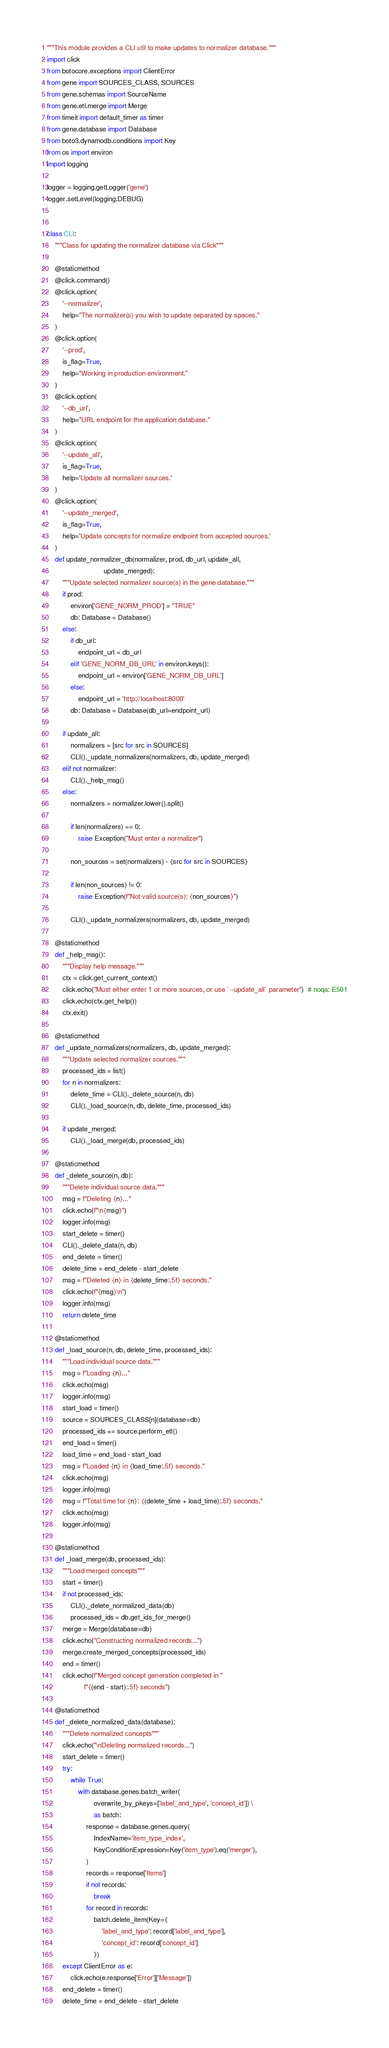<code> <loc_0><loc_0><loc_500><loc_500><_Python_>"""This module provides a CLI util to make updates to normalizer database."""
import click
from botocore.exceptions import ClientError
from gene import SOURCES_CLASS, SOURCES
from gene.schemas import SourceName
from gene.etl.merge import Merge
from timeit import default_timer as timer
from gene.database import Database
from boto3.dynamodb.conditions import Key
from os import environ
import logging

logger = logging.getLogger('gene')
logger.setLevel(logging.DEBUG)


class CLI:
    """Class for updating the normalizer database via Click"""

    @staticmethod
    @click.command()
    @click.option(
        '--normalizer',
        help="The normalizer(s) you wish to update separated by spaces."
    )
    @click.option(
        '--prod',
        is_flag=True,
        help="Working in production environment."
    )
    @click.option(
        '--db_url',
        help="URL endpoint for the application database."
    )
    @click.option(
        '--update_all',
        is_flag=True,
        help='Update all normalizer sources.'
    )
    @click.option(
        '--update_merged',
        is_flag=True,
        help='Update concepts for normalize endpoint from accepted sources.'
    )
    def update_normalizer_db(normalizer, prod, db_url, update_all,
                             update_merged):
        """Update selected normalizer source(s) in the gene database."""
        if prod:
            environ['GENE_NORM_PROD'] = "TRUE"
            db: Database = Database()
        else:
            if db_url:
                endpoint_url = db_url
            elif 'GENE_NORM_DB_URL' in environ.keys():
                endpoint_url = environ['GENE_NORM_DB_URL']
            else:
                endpoint_url = 'http://localhost:8000'
            db: Database = Database(db_url=endpoint_url)

        if update_all:
            normalizers = [src for src in SOURCES]
            CLI()._update_normalizers(normalizers, db, update_merged)
        elif not normalizer:
            CLI()._help_msg()
        else:
            normalizers = normalizer.lower().split()

            if len(normalizers) == 0:
                raise Exception("Must enter a normalizer")

            non_sources = set(normalizers) - {src for src in SOURCES}

            if len(non_sources) != 0:
                raise Exception(f"Not valid source(s): {non_sources}")

            CLI()._update_normalizers(normalizers, db, update_merged)

    @staticmethod
    def _help_msg():
        """Display help message."""
        ctx = click.get_current_context()
        click.echo("Must either enter 1 or more sources, or use `--update_all` parameter")  # noqa: E501
        click.echo(ctx.get_help())
        ctx.exit()

    @staticmethod
    def _update_normalizers(normalizers, db, update_merged):
        """Update selected normalizer sources."""
        processed_ids = list()
        for n in normalizers:
            delete_time = CLI()._delete_source(n, db)
            CLI()._load_source(n, db, delete_time, processed_ids)

        if update_merged:
            CLI()._load_merge(db, processed_ids)

    @staticmethod
    def _delete_source(n, db):
        """Delete individual source data."""
        msg = f"Deleting {n}..."
        click.echo(f"\n{msg}")
        logger.info(msg)
        start_delete = timer()
        CLI()._delete_data(n, db)
        end_delete = timer()
        delete_time = end_delete - start_delete
        msg = f"Deleted {n} in {delete_time:.5f} seconds."
        click.echo(f"{msg}\n")
        logger.info(msg)
        return delete_time

    @staticmethod
    def _load_source(n, db, delete_time, processed_ids):
        """Load individual source data."""
        msg = f"Loading {n}..."
        click.echo(msg)
        logger.info(msg)
        start_load = timer()
        source = SOURCES_CLASS[n](database=db)
        processed_ids += source.perform_etl()
        end_load = timer()
        load_time = end_load - start_load
        msg = f"Loaded {n} in {load_time:.5f} seconds."
        click.echo(msg)
        logger.info(msg)
        msg = f"Total time for {n}: {(delete_time + load_time):.5f} seconds."
        click.echo(msg)
        logger.info(msg)

    @staticmethod
    def _load_merge(db, processed_ids):
        """Load merged concepts"""
        start = timer()
        if not processed_ids:
            CLI()._delete_normalized_data(db)
            processed_ids = db.get_ids_for_merge()
        merge = Merge(database=db)
        click.echo("Constructing normalized records...")
        merge.create_merged_concepts(processed_ids)
        end = timer()
        click.echo(f"Merged concept generation completed in "
                   f"{(end - start):.5f} seconds")

    @staticmethod
    def _delete_normalized_data(database):
        """Delete normalized concepts"""
        click.echo("\nDeleting normalized records...")
        start_delete = timer()
        try:
            while True:
                with database.genes.batch_writer(
                        overwrite_by_pkeys=['label_and_type', 'concept_id']) \
                        as batch:
                    response = database.genes.query(
                        IndexName='item_type_index',
                        KeyConditionExpression=Key('item_type').eq('merger'),
                    )
                    records = response['Items']
                    if not records:
                        break
                    for record in records:
                        batch.delete_item(Key={
                            'label_and_type': record['label_and_type'],
                            'concept_id': record['concept_id']
                        })
        except ClientError as e:
            click.echo(e.response['Error']['Message'])
        end_delete = timer()
        delete_time = end_delete - start_delete</code> 